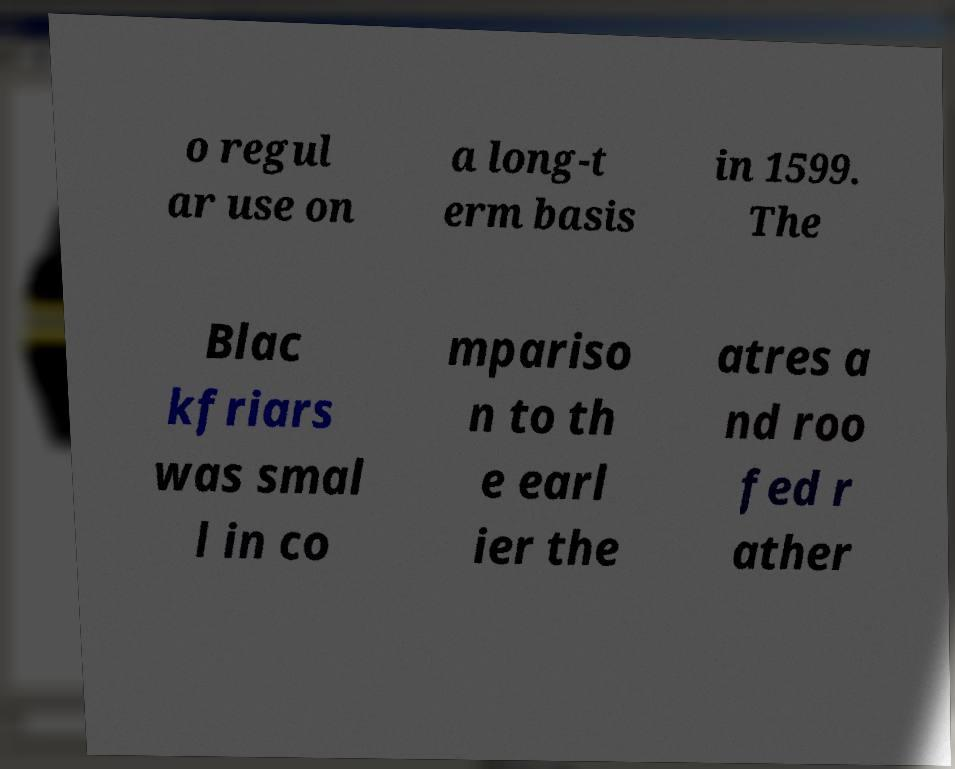For documentation purposes, I need the text within this image transcribed. Could you provide that? o regul ar use on a long-t erm basis in 1599. The Blac kfriars was smal l in co mpariso n to th e earl ier the atres a nd roo fed r ather 